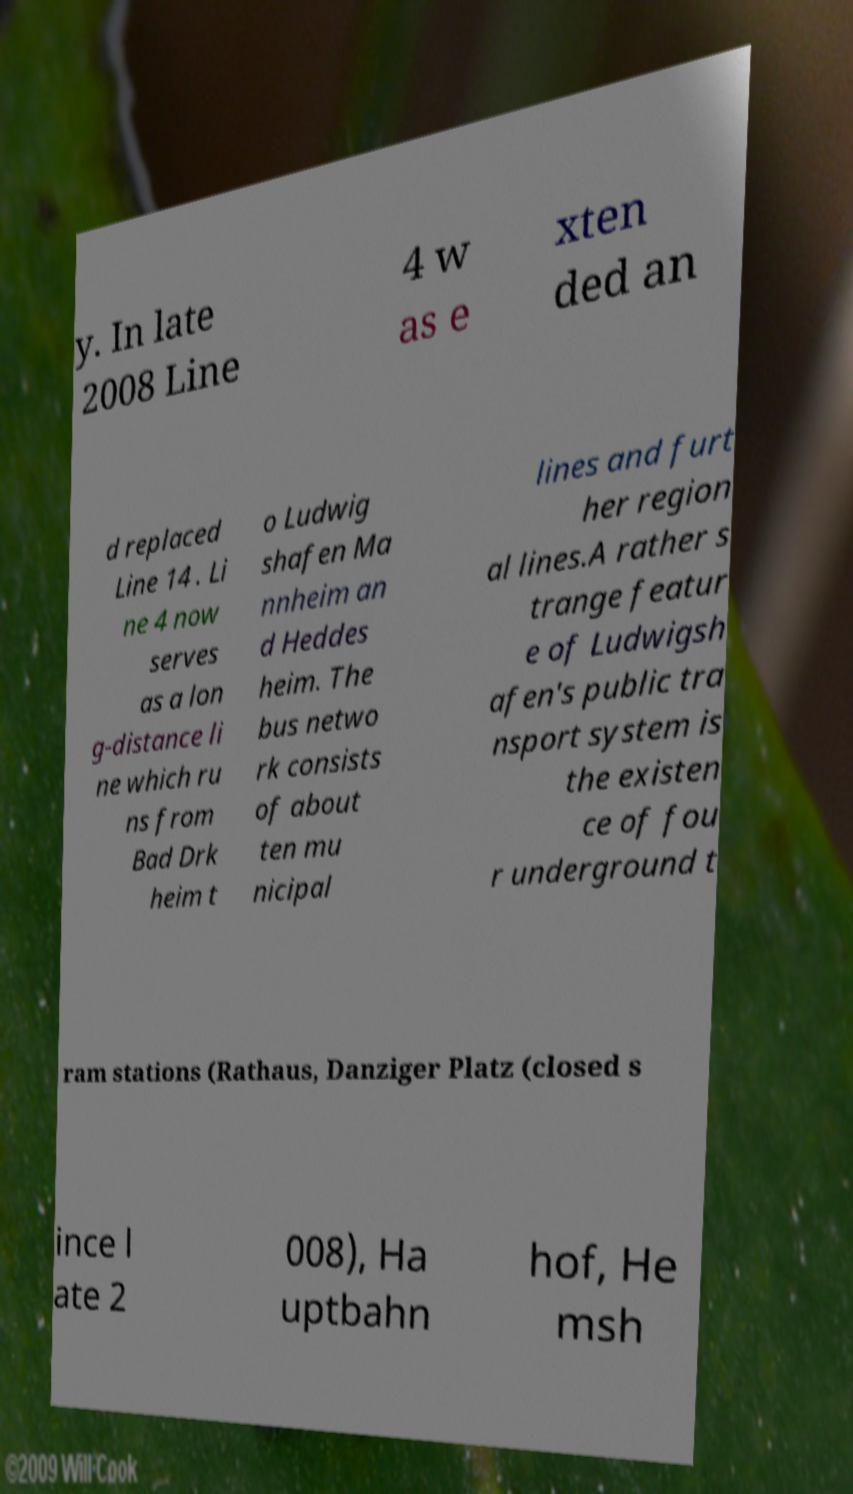Can you accurately transcribe the text from the provided image for me? y. In late 2008 Line 4 w as e xten ded an d replaced Line 14 . Li ne 4 now serves as a lon g-distance li ne which ru ns from Bad Drk heim t o Ludwig shafen Ma nnheim an d Heddes heim. The bus netwo rk consists of about ten mu nicipal lines and furt her region al lines.A rather s trange featur e of Ludwigsh afen's public tra nsport system is the existen ce of fou r underground t ram stations (Rathaus, Danziger Platz (closed s ince l ate 2 008), Ha uptbahn hof, He msh 